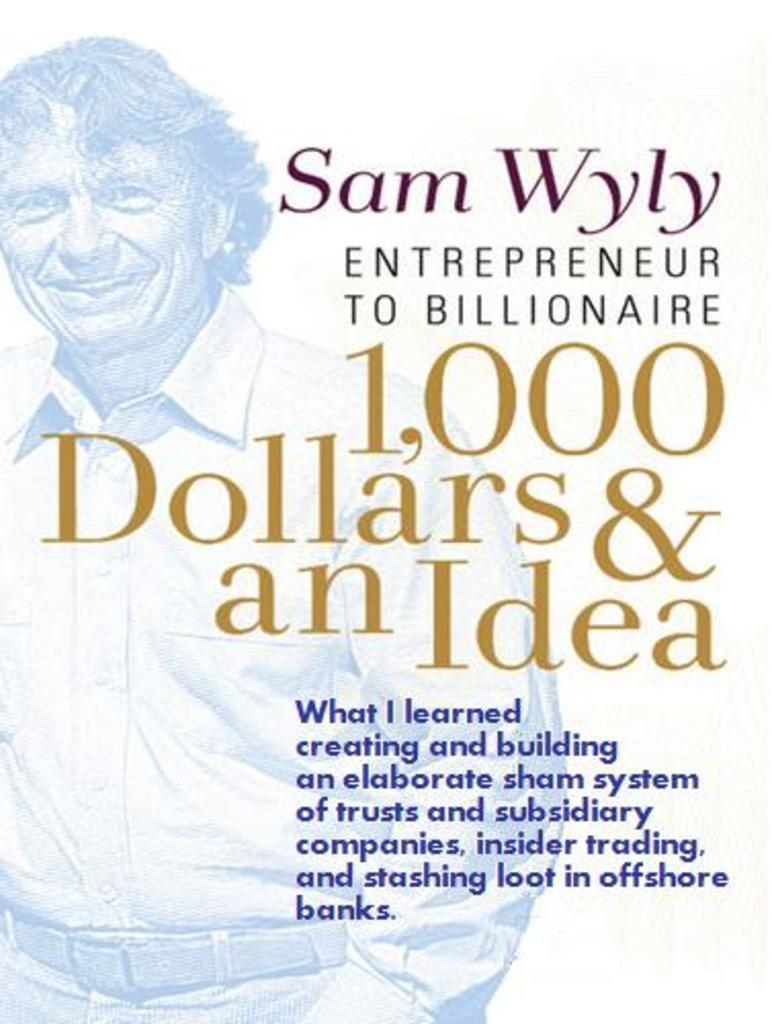What is depicted on the poster in the picture? The poster features a man wearing a shirt. What is the facial expression of the man on the poster? The man on the poster has a smile on his face. Where is the text located on the poster? The text is on the right side of the poster. Can you see any buildings in the background of the poster? There is no background visible in the poster, as it only features the man wearing a shirt and the text on the right side. 